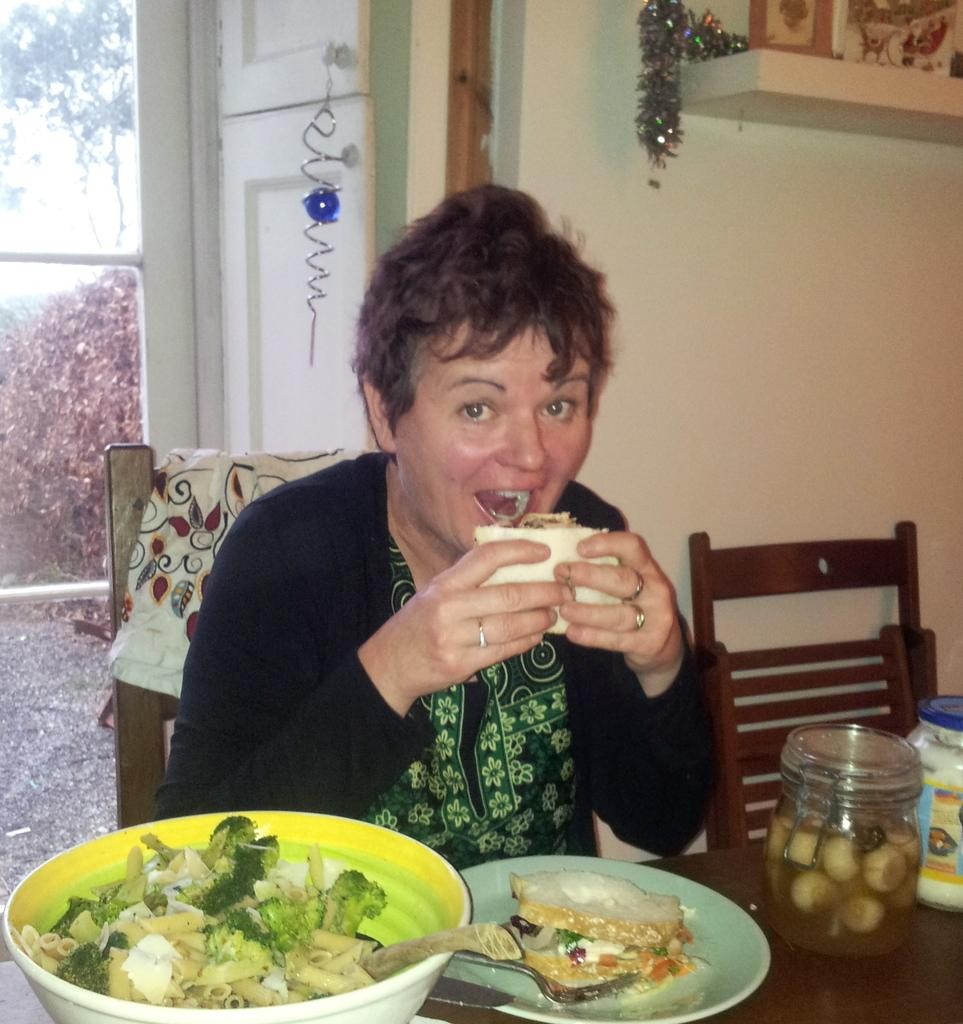Who is present in the image? There is a woman in the image. What is the woman doing in the image? The woman is seated on a chair and eating food. How is the food being held in the image? The food is held in her hands. What objects can be seen on the table in the image? There is a bowl, a plate, a jar, and a sauce bottle on the table. What type of news is the woman reading in the image? There is no news present in the image; the woman is eating food and not reading anything. What brand of toothpaste is on the table in the image? There is no toothpaste present in the image; the objects on the table are a bowl, a plate, a jar, and a sauce bottle. 